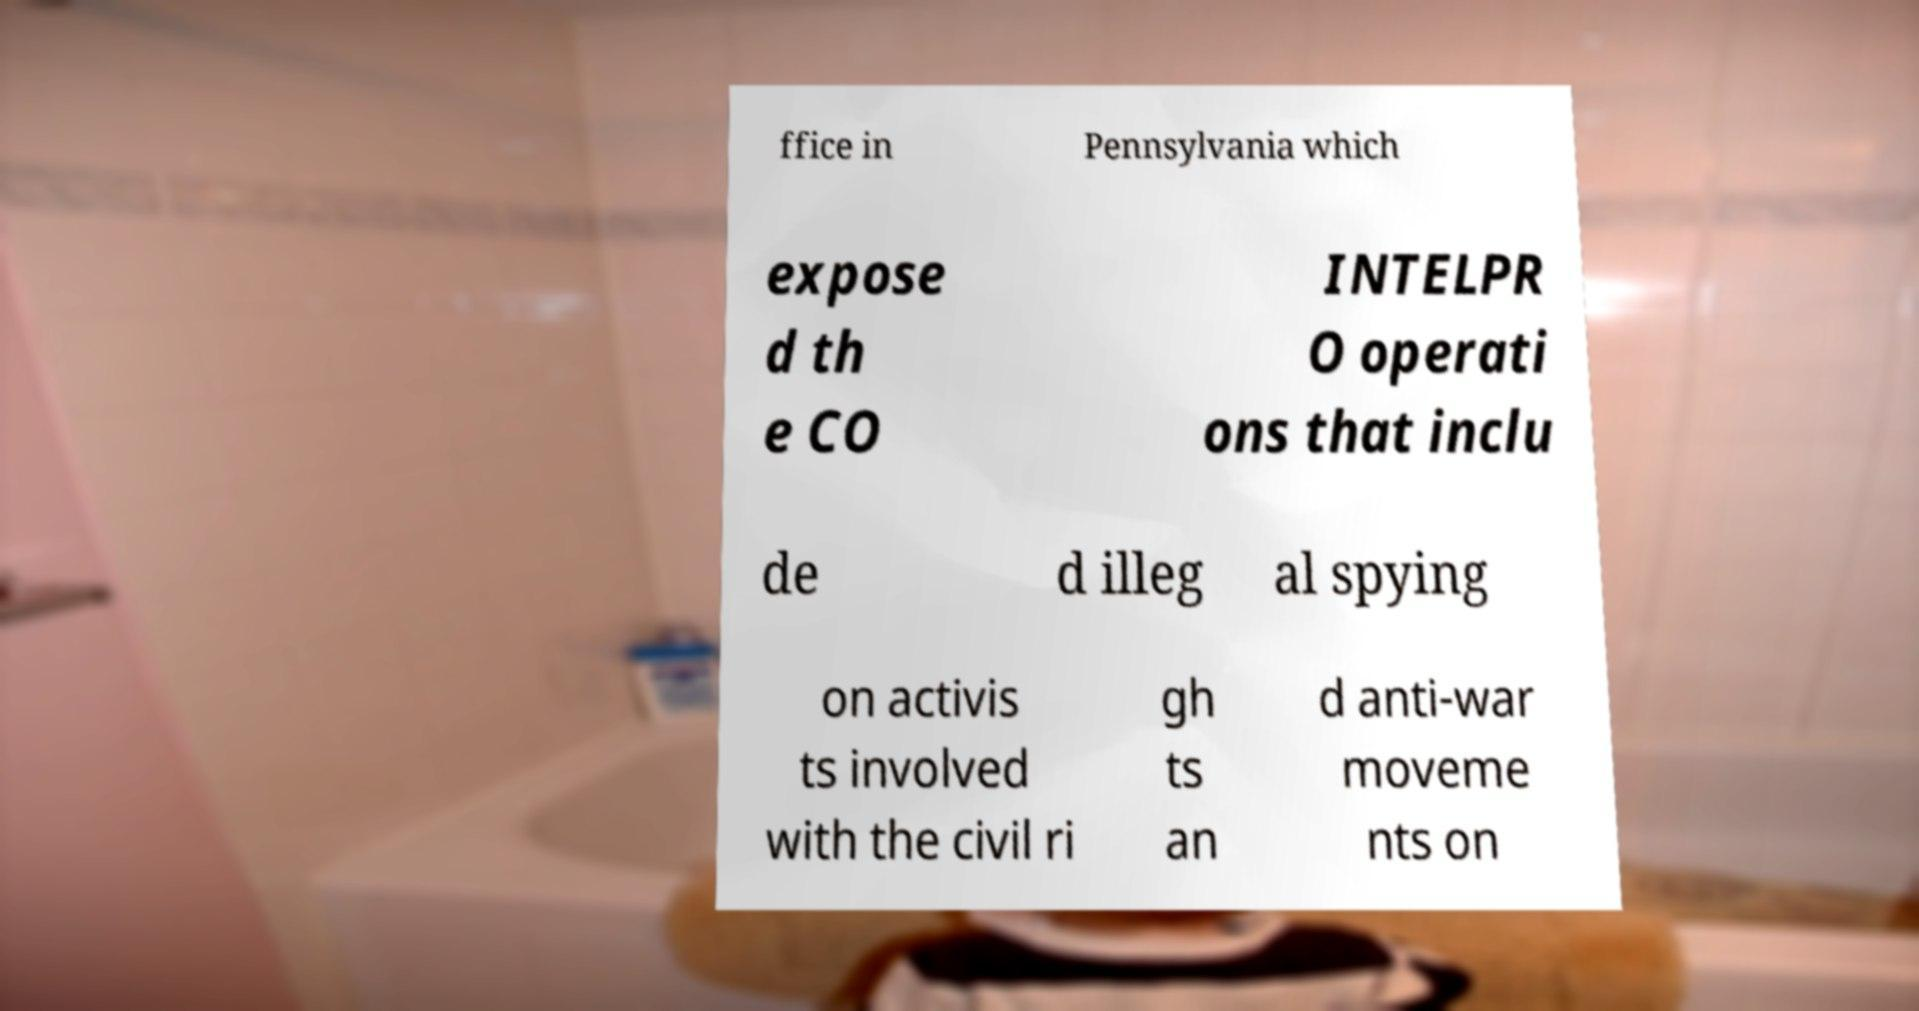Please read and relay the text visible in this image. What does it say? ffice in Pennsylvania which expose d th e CO INTELPR O operati ons that inclu de d illeg al spying on activis ts involved with the civil ri gh ts an d anti-war moveme nts on 